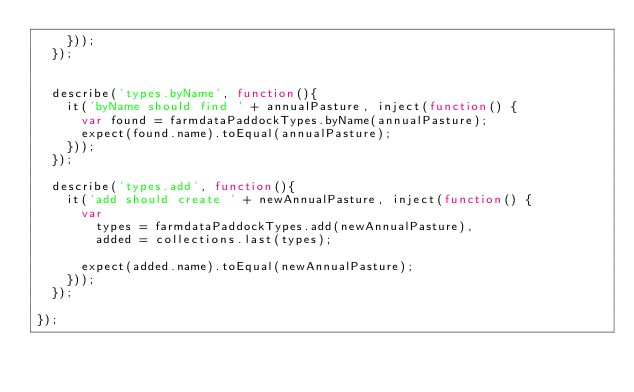Convert code to text. <code><loc_0><loc_0><loc_500><loc_500><_JavaScript_>    }));
  });


  describe('types.byName', function(){
    it('byName should find ' + annualPasture, inject(function() {
      var found = farmdataPaddockTypes.byName(annualPasture);
      expect(found.name).toEqual(annualPasture);
    }));
  });

  describe('types.add', function(){
    it('add should create ' + newAnnualPasture, inject(function() {
      var
        types = farmdataPaddockTypes.add(newAnnualPasture),
        added = collections.last(types);

      expect(added.name).toEqual(newAnnualPasture);
    }));
  });

});

</code> 